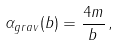Convert formula to latex. <formula><loc_0><loc_0><loc_500><loc_500>\alpha _ { g r a v } ( b ) = \frac { 4 m } { b } \, ,</formula> 